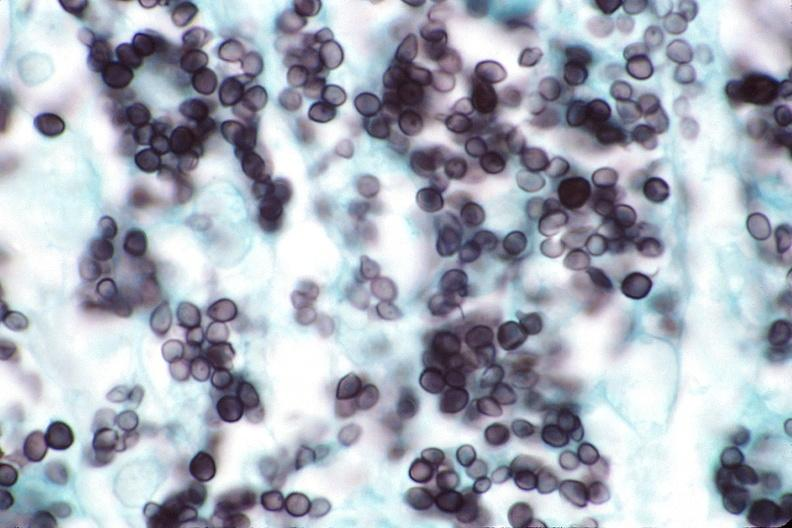does this image show lung, histoplasma pneumonia?
Answer the question using a single word or phrase. Yes 